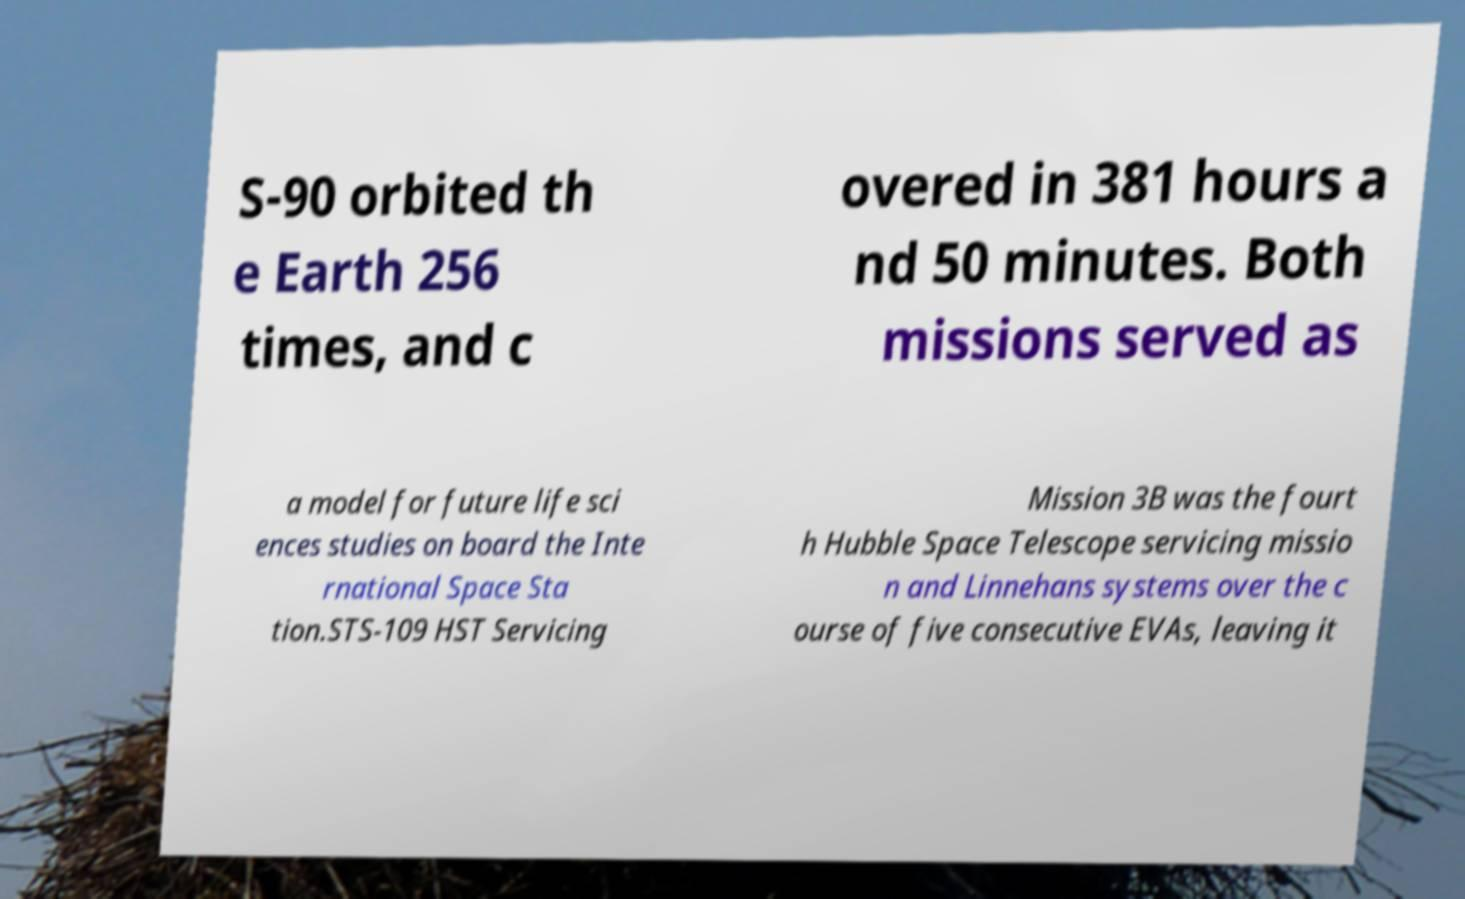What messages or text are displayed in this image? I need them in a readable, typed format. S-90 orbited th e Earth 256 times, and c overed in 381 hours a nd 50 minutes. Both missions served as a model for future life sci ences studies on board the Inte rnational Space Sta tion.STS-109 HST Servicing Mission 3B was the fourt h Hubble Space Telescope servicing missio n and Linnehans systems over the c ourse of five consecutive EVAs, leaving it 